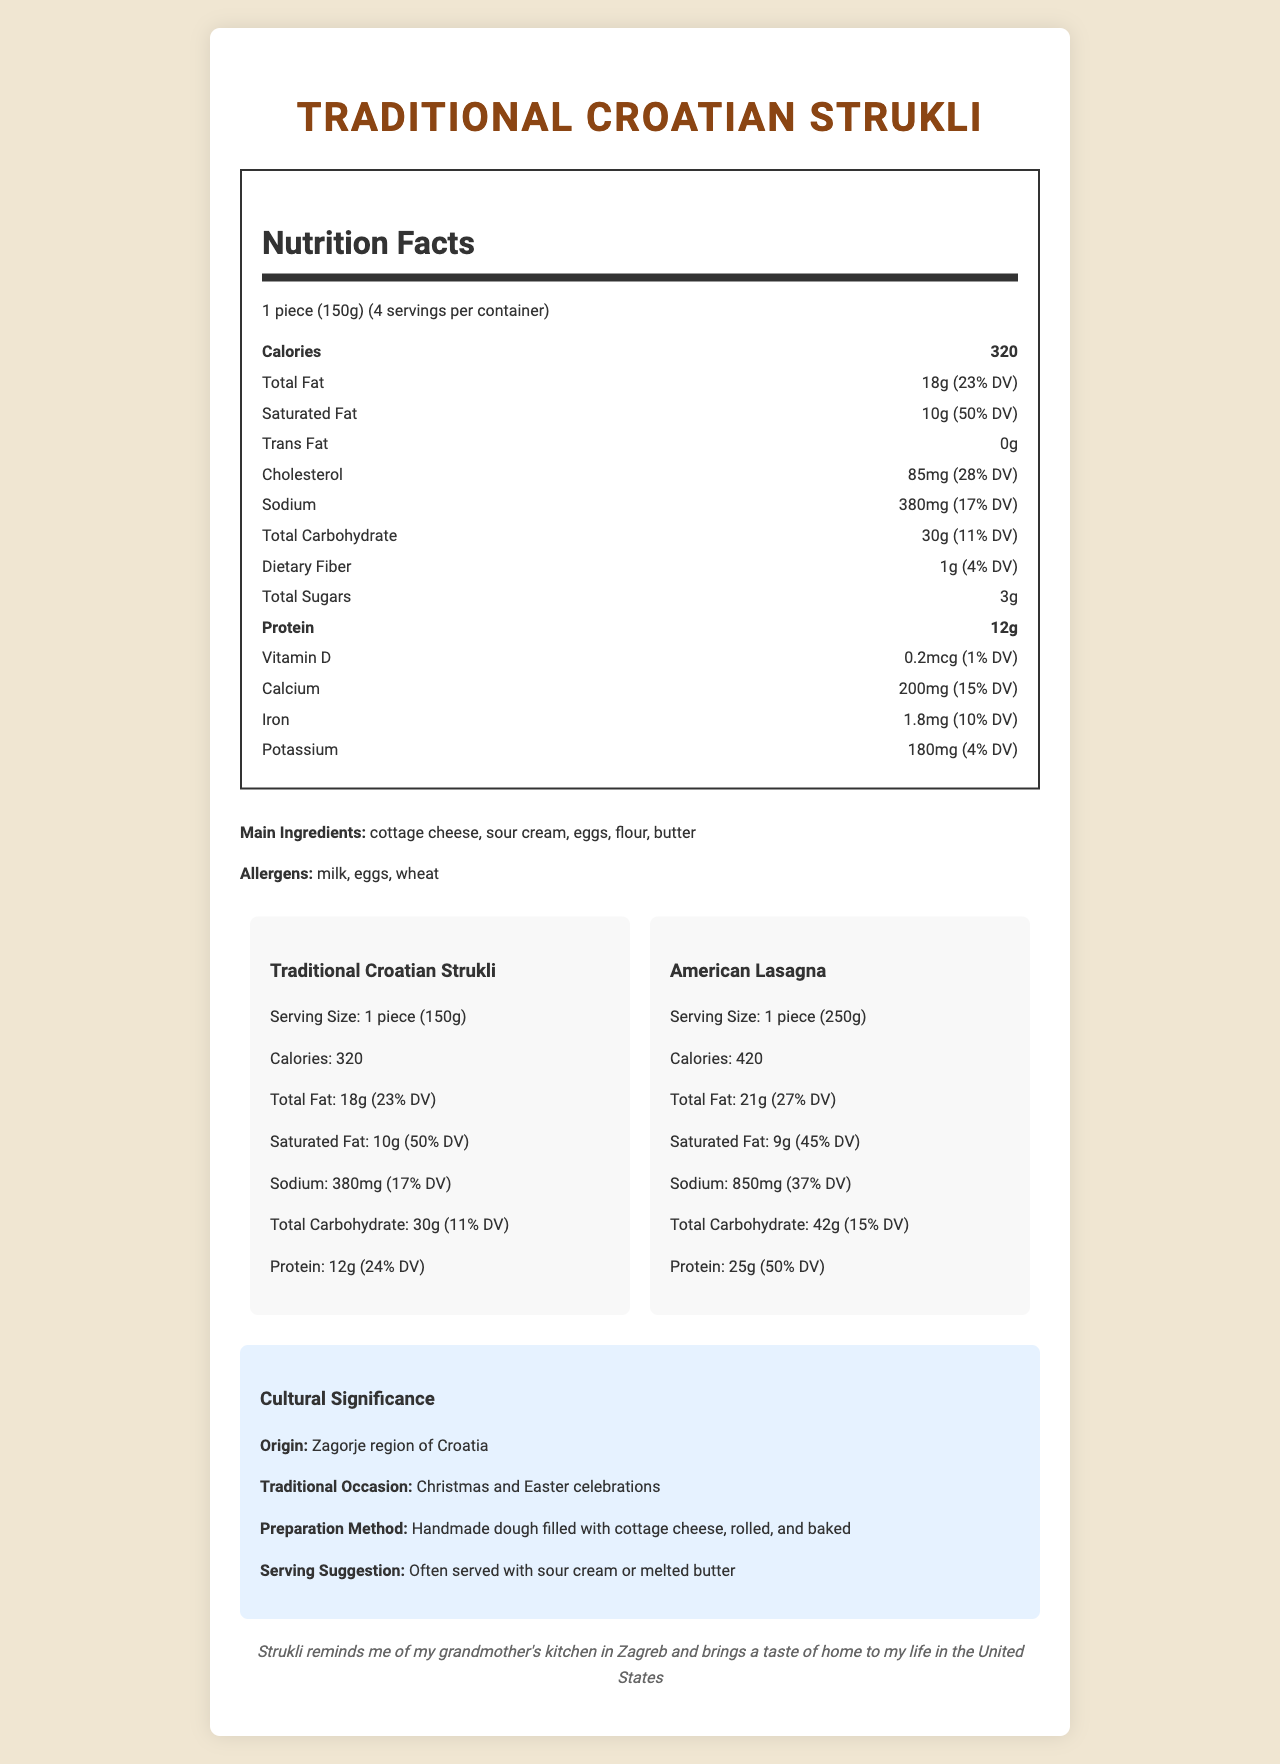what is the serving size of Traditional Croatian Strukli? The document lists the serving size for Traditional Croatian Strukli as "1 piece (150g)".
Answer: 1 piece (150g) how many servings per container for Traditional Croatian Strukli? The document indicates there are 4 servings per container.
Answer: 4 what is the total carbohydrate content in American Lasagna per serving? According to the comparison section, American Lasagna has 42g of total carbohydrates per serving.
Answer: 42g how much protein does one serving of Traditional Croatian Strukli contain? The document specifies that one serving of Traditional Croatian Strukli contains 12g of protein.
Answer: 12g which dish has more sodium per serving, Traditional Croatian Strukli or American Lasagna? The document states that Traditional Croatian Strukli has 380mg of sodium per serving, while American Lasagna has 850mg, making American Lasagna higher in sodium.
Answer: American Lasagna which of the following is NOT an ingredient in Traditional Croatian Strukli? A. Cottage Cheese B. Flour C. Tomato Sauce D. Eggs The main ingredients listed for Traditional Croatian Strukli are cottage cheese, sour cream, eggs, flour, and butter, which does not include tomato sauce.
Answer: C. Tomato Sauce which nutrient in Traditional Croatian Strukli contributes the highest percentage to the daily value? A. Saturated Fat B. Dietary Fiber C. Protein D. Iron The document indicates that saturated fat in Traditional Croatian Strukli has a daily value of 50%, the highest among the listed nutrients.
Answer: A. Saturated Fat are there any trans fats in Traditional Croatian Strukli? The document specifies 0g of trans fats in Traditional Croatian Strukli.
Answer: No is American Lasagna higher in calories than Traditional Croatian Strukli? The comparison shows that American Lasagna has 420 calories per serving, whereas Traditional Croatian Strukli has 320 calories.
Answer: Yes summarize the main nutritional differences between Traditional Croatian Strukli and American Lasagna. The document provides a detailed comparison: Strukli has 320 calories and 380mg sodium per 150g serving, while Lasagna has 420 calories and 850mg sodium per 250g serving. Strukli has 12g protein, and Lasagna has 25g protein.
Answer: Traditional Croatian Strukli has fewer calories and sodium but also less protein compared to American Lasagna. Strukli has higher saturated fat and a lower carbohydrate content per serving. Strukli's serving size is smaller than that of Lasagna. is the preparation method of Traditional Croatian Strukli automated or handmade? The document states that the preparation method for Strukli involves handmade dough filled with cottage cheese, rolled, and baked.
Answer: Handmade does the document provide the recipe for Traditional Croatian Strukli? The document describes the preparation method but does not provide a detailed recipe or steps for making Strukli.
Answer: Not enough information what is the cultural significance of Traditional Croatian Strukli? The document highlights that Strukli is culturally significant, originating in the Zagorje region, and is associated with festive occasions like Christmas and Easter. The preparation is handmade, and common serving suggestions include sour cream or melted butter.
Answer: Strukli originates from the Zagorje region of Croatia and is traditionally prepared during Christmas and Easter celebrations. It is often served with sour cream or melted butter. 